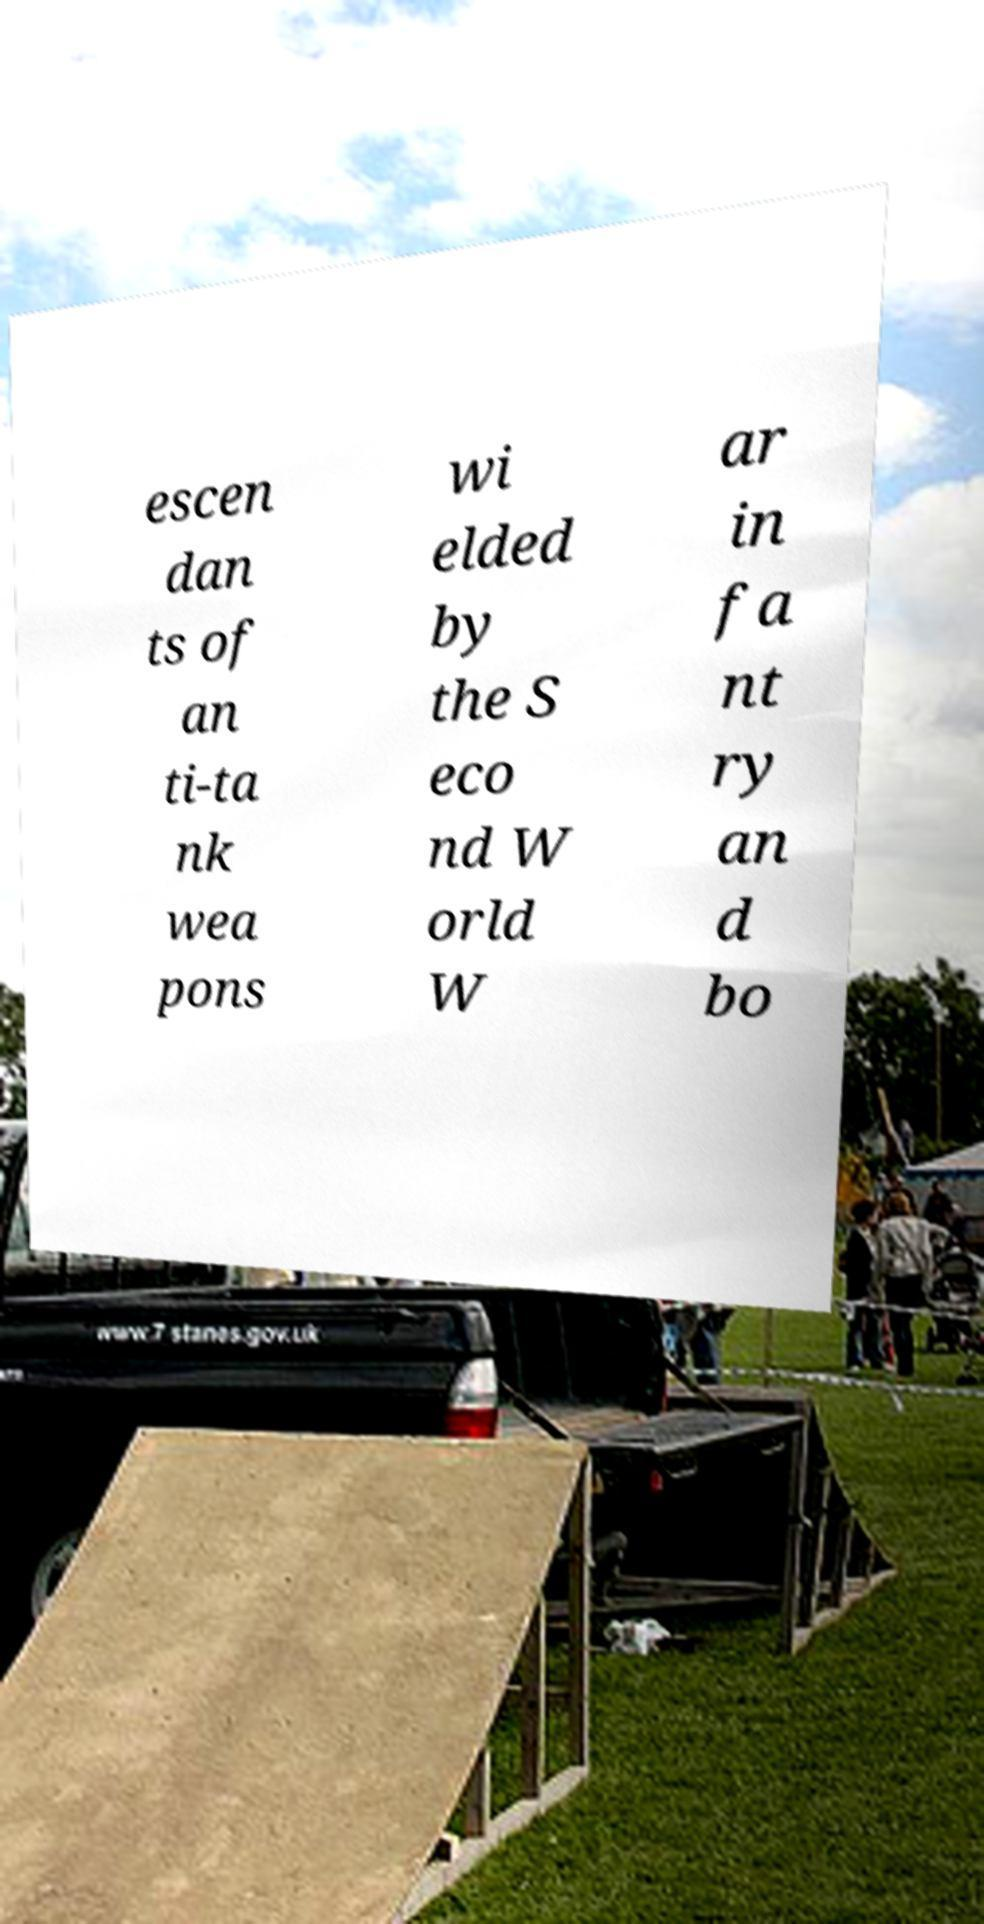Please identify and transcribe the text found in this image. escen dan ts of an ti-ta nk wea pons wi elded by the S eco nd W orld W ar in fa nt ry an d bo 